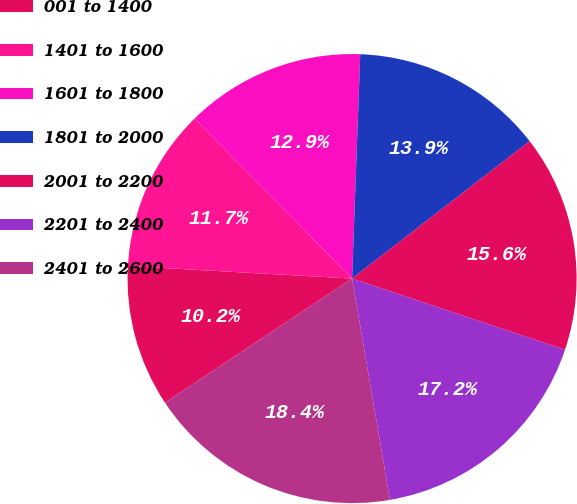Convert chart. <chart><loc_0><loc_0><loc_500><loc_500><pie_chart><fcel>001 to 1400<fcel>1401 to 1600<fcel>1601 to 1800<fcel>1801 to 2000<fcel>2001 to 2200<fcel>2201 to 2400<fcel>2401 to 2600<nl><fcel>10.21%<fcel>11.74%<fcel>12.95%<fcel>13.94%<fcel>15.62%<fcel>17.16%<fcel>18.38%<nl></chart> 